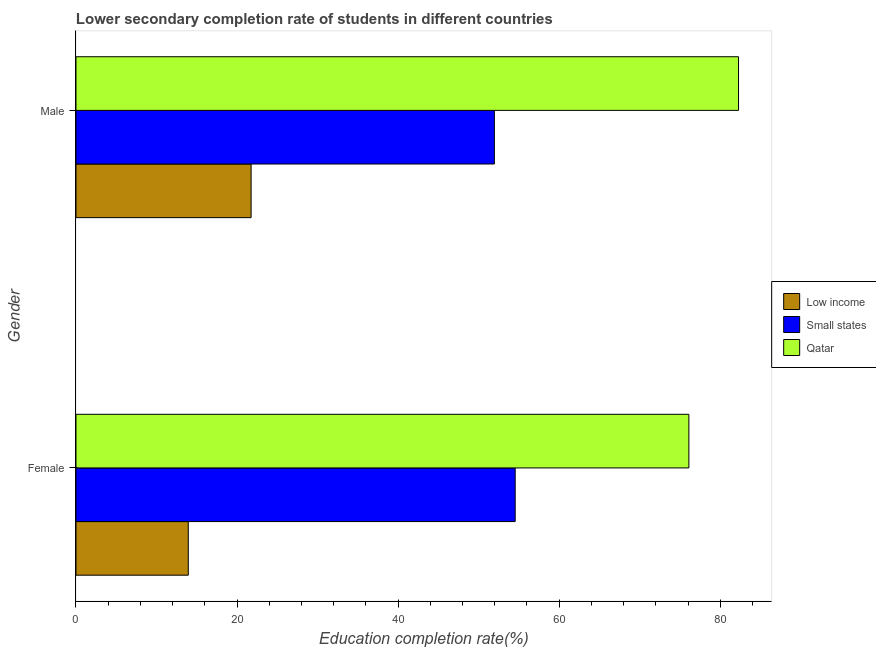How many different coloured bars are there?
Your answer should be compact. 3. Are the number of bars per tick equal to the number of legend labels?
Provide a succinct answer. Yes. Are the number of bars on each tick of the Y-axis equal?
Make the answer very short. Yes. How many bars are there on the 1st tick from the top?
Your answer should be very brief. 3. How many bars are there on the 2nd tick from the bottom?
Ensure brevity in your answer.  3. What is the label of the 2nd group of bars from the top?
Offer a terse response. Female. What is the education completion rate of female students in Low income?
Make the answer very short. 13.94. Across all countries, what is the maximum education completion rate of male students?
Your answer should be very brief. 82.27. Across all countries, what is the minimum education completion rate of female students?
Offer a very short reply. 13.94. In which country was the education completion rate of female students maximum?
Ensure brevity in your answer.  Qatar. In which country was the education completion rate of male students minimum?
Ensure brevity in your answer.  Low income. What is the total education completion rate of male students in the graph?
Give a very brief answer. 155.97. What is the difference between the education completion rate of male students in Low income and that in Qatar?
Provide a short and direct response. -60.53. What is the difference between the education completion rate of female students in Qatar and the education completion rate of male students in Low income?
Make the answer very short. 54.36. What is the average education completion rate of female students per country?
Keep it short and to the point. 48.2. What is the difference between the education completion rate of male students and education completion rate of female students in Low income?
Your answer should be compact. 7.8. What is the ratio of the education completion rate of male students in Qatar to that in Small states?
Provide a succinct answer. 1.58. Is the education completion rate of male students in Small states less than that in Low income?
Ensure brevity in your answer.  No. What does the 3rd bar from the top in Female represents?
Offer a very short reply. Low income. What does the 1st bar from the bottom in Male represents?
Your response must be concise. Low income. How many bars are there?
Your answer should be very brief. 6. Are all the bars in the graph horizontal?
Your answer should be very brief. Yes. How many countries are there in the graph?
Your response must be concise. 3. What is the difference between two consecutive major ticks on the X-axis?
Your answer should be very brief. 20. Are the values on the major ticks of X-axis written in scientific E-notation?
Give a very brief answer. No. How many legend labels are there?
Make the answer very short. 3. How are the legend labels stacked?
Ensure brevity in your answer.  Vertical. What is the title of the graph?
Keep it short and to the point. Lower secondary completion rate of students in different countries. Does "Maldives" appear as one of the legend labels in the graph?
Provide a succinct answer. No. What is the label or title of the X-axis?
Ensure brevity in your answer.  Education completion rate(%). What is the label or title of the Y-axis?
Keep it short and to the point. Gender. What is the Education completion rate(%) in Low income in Female?
Provide a succinct answer. 13.94. What is the Education completion rate(%) of Small states in Female?
Provide a succinct answer. 54.54. What is the Education completion rate(%) in Qatar in Female?
Keep it short and to the point. 76.11. What is the Education completion rate(%) in Low income in Male?
Your answer should be very brief. 21.74. What is the Education completion rate(%) of Small states in Male?
Your answer should be very brief. 51.95. What is the Education completion rate(%) of Qatar in Male?
Offer a terse response. 82.27. Across all Gender, what is the maximum Education completion rate(%) in Low income?
Offer a terse response. 21.74. Across all Gender, what is the maximum Education completion rate(%) in Small states?
Ensure brevity in your answer.  54.54. Across all Gender, what is the maximum Education completion rate(%) of Qatar?
Offer a terse response. 82.27. Across all Gender, what is the minimum Education completion rate(%) in Low income?
Keep it short and to the point. 13.94. Across all Gender, what is the minimum Education completion rate(%) of Small states?
Your response must be concise. 51.95. Across all Gender, what is the minimum Education completion rate(%) of Qatar?
Keep it short and to the point. 76.11. What is the total Education completion rate(%) of Low income in the graph?
Provide a succinct answer. 35.69. What is the total Education completion rate(%) in Small states in the graph?
Your answer should be very brief. 106.49. What is the total Education completion rate(%) in Qatar in the graph?
Provide a succinct answer. 158.38. What is the difference between the Education completion rate(%) in Low income in Female and that in Male?
Keep it short and to the point. -7.8. What is the difference between the Education completion rate(%) in Small states in Female and that in Male?
Offer a terse response. 2.58. What is the difference between the Education completion rate(%) of Qatar in Female and that in Male?
Give a very brief answer. -6.17. What is the difference between the Education completion rate(%) of Low income in Female and the Education completion rate(%) of Small states in Male?
Your answer should be very brief. -38.01. What is the difference between the Education completion rate(%) in Low income in Female and the Education completion rate(%) in Qatar in Male?
Provide a short and direct response. -68.33. What is the difference between the Education completion rate(%) in Small states in Female and the Education completion rate(%) in Qatar in Male?
Keep it short and to the point. -27.73. What is the average Education completion rate(%) of Low income per Gender?
Your response must be concise. 17.84. What is the average Education completion rate(%) in Small states per Gender?
Provide a succinct answer. 53.25. What is the average Education completion rate(%) in Qatar per Gender?
Offer a very short reply. 79.19. What is the difference between the Education completion rate(%) of Low income and Education completion rate(%) of Small states in Female?
Offer a very short reply. -40.59. What is the difference between the Education completion rate(%) in Low income and Education completion rate(%) in Qatar in Female?
Make the answer very short. -62.16. What is the difference between the Education completion rate(%) in Small states and Education completion rate(%) in Qatar in Female?
Your answer should be very brief. -21.57. What is the difference between the Education completion rate(%) of Low income and Education completion rate(%) of Small states in Male?
Give a very brief answer. -30.21. What is the difference between the Education completion rate(%) of Low income and Education completion rate(%) of Qatar in Male?
Make the answer very short. -60.53. What is the difference between the Education completion rate(%) in Small states and Education completion rate(%) in Qatar in Male?
Provide a succinct answer. -30.32. What is the ratio of the Education completion rate(%) in Low income in Female to that in Male?
Keep it short and to the point. 0.64. What is the ratio of the Education completion rate(%) in Small states in Female to that in Male?
Offer a terse response. 1.05. What is the ratio of the Education completion rate(%) in Qatar in Female to that in Male?
Provide a short and direct response. 0.93. What is the difference between the highest and the second highest Education completion rate(%) of Low income?
Provide a succinct answer. 7.8. What is the difference between the highest and the second highest Education completion rate(%) in Small states?
Offer a very short reply. 2.58. What is the difference between the highest and the second highest Education completion rate(%) in Qatar?
Offer a terse response. 6.17. What is the difference between the highest and the lowest Education completion rate(%) in Low income?
Your answer should be compact. 7.8. What is the difference between the highest and the lowest Education completion rate(%) in Small states?
Your answer should be compact. 2.58. What is the difference between the highest and the lowest Education completion rate(%) in Qatar?
Ensure brevity in your answer.  6.17. 